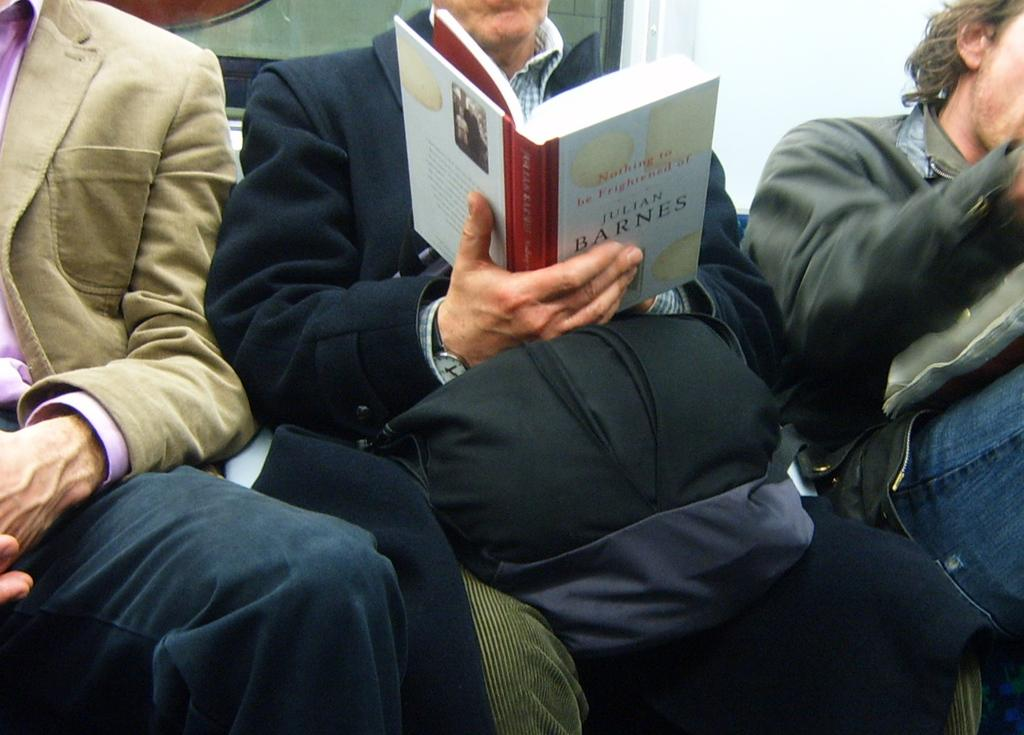<image>
Give a short and clear explanation of the subsequent image. A man is reading Nothing to Be Frightened of as he sits on public transit. 